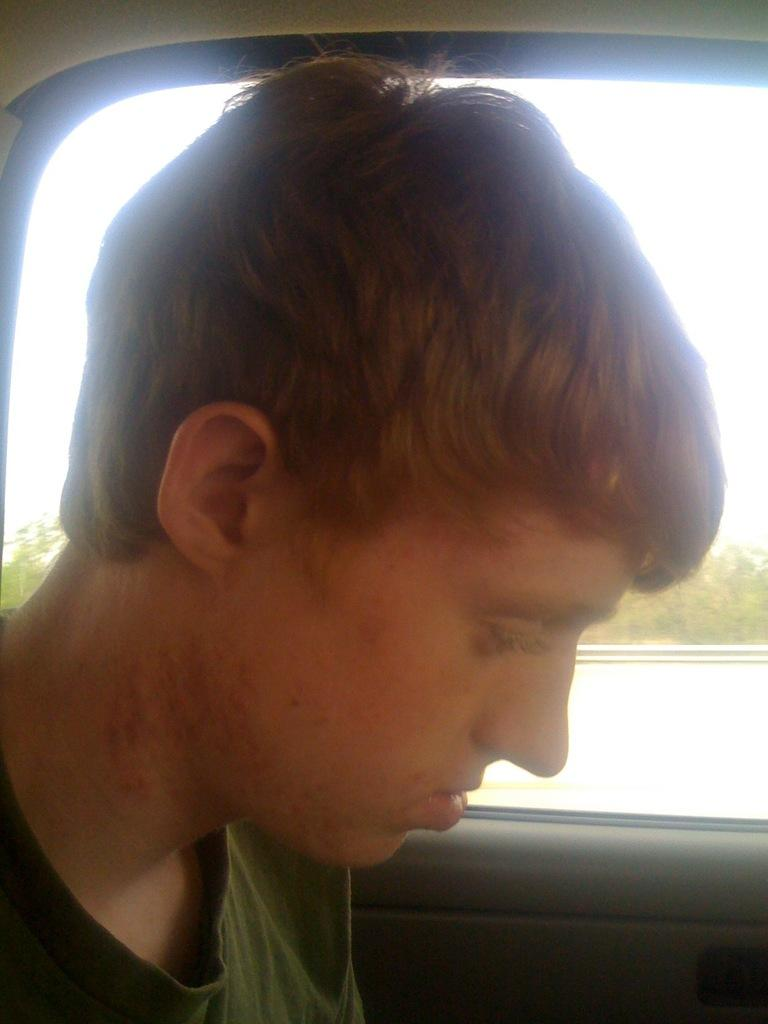Who is present in the image? There is a man in the image. What can be seen through the window in the image? A window is visible in the image, and through it, the sky can be seen. What type of vegetation is present in the image? There are plants in the image. What type of glue is being used to hold the man's hands together in the image? There is no glue or indication of restraint in the image; the man's hands are not shown to be held together. 